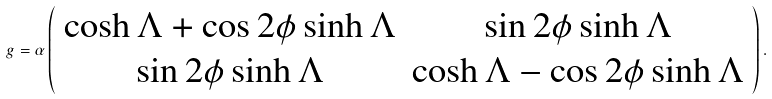<formula> <loc_0><loc_0><loc_500><loc_500>g = \alpha \left ( \begin{array} { c c } \cosh { \Lambda } + \cos 2 \phi \sinh { \Lambda } & \sin 2 \phi \sinh { \Lambda } \\ \sin 2 \phi \sinh { \Lambda } & \cosh { \Lambda } - \cos 2 \phi \sinh { \Lambda } \end{array} \right ) .</formula> 